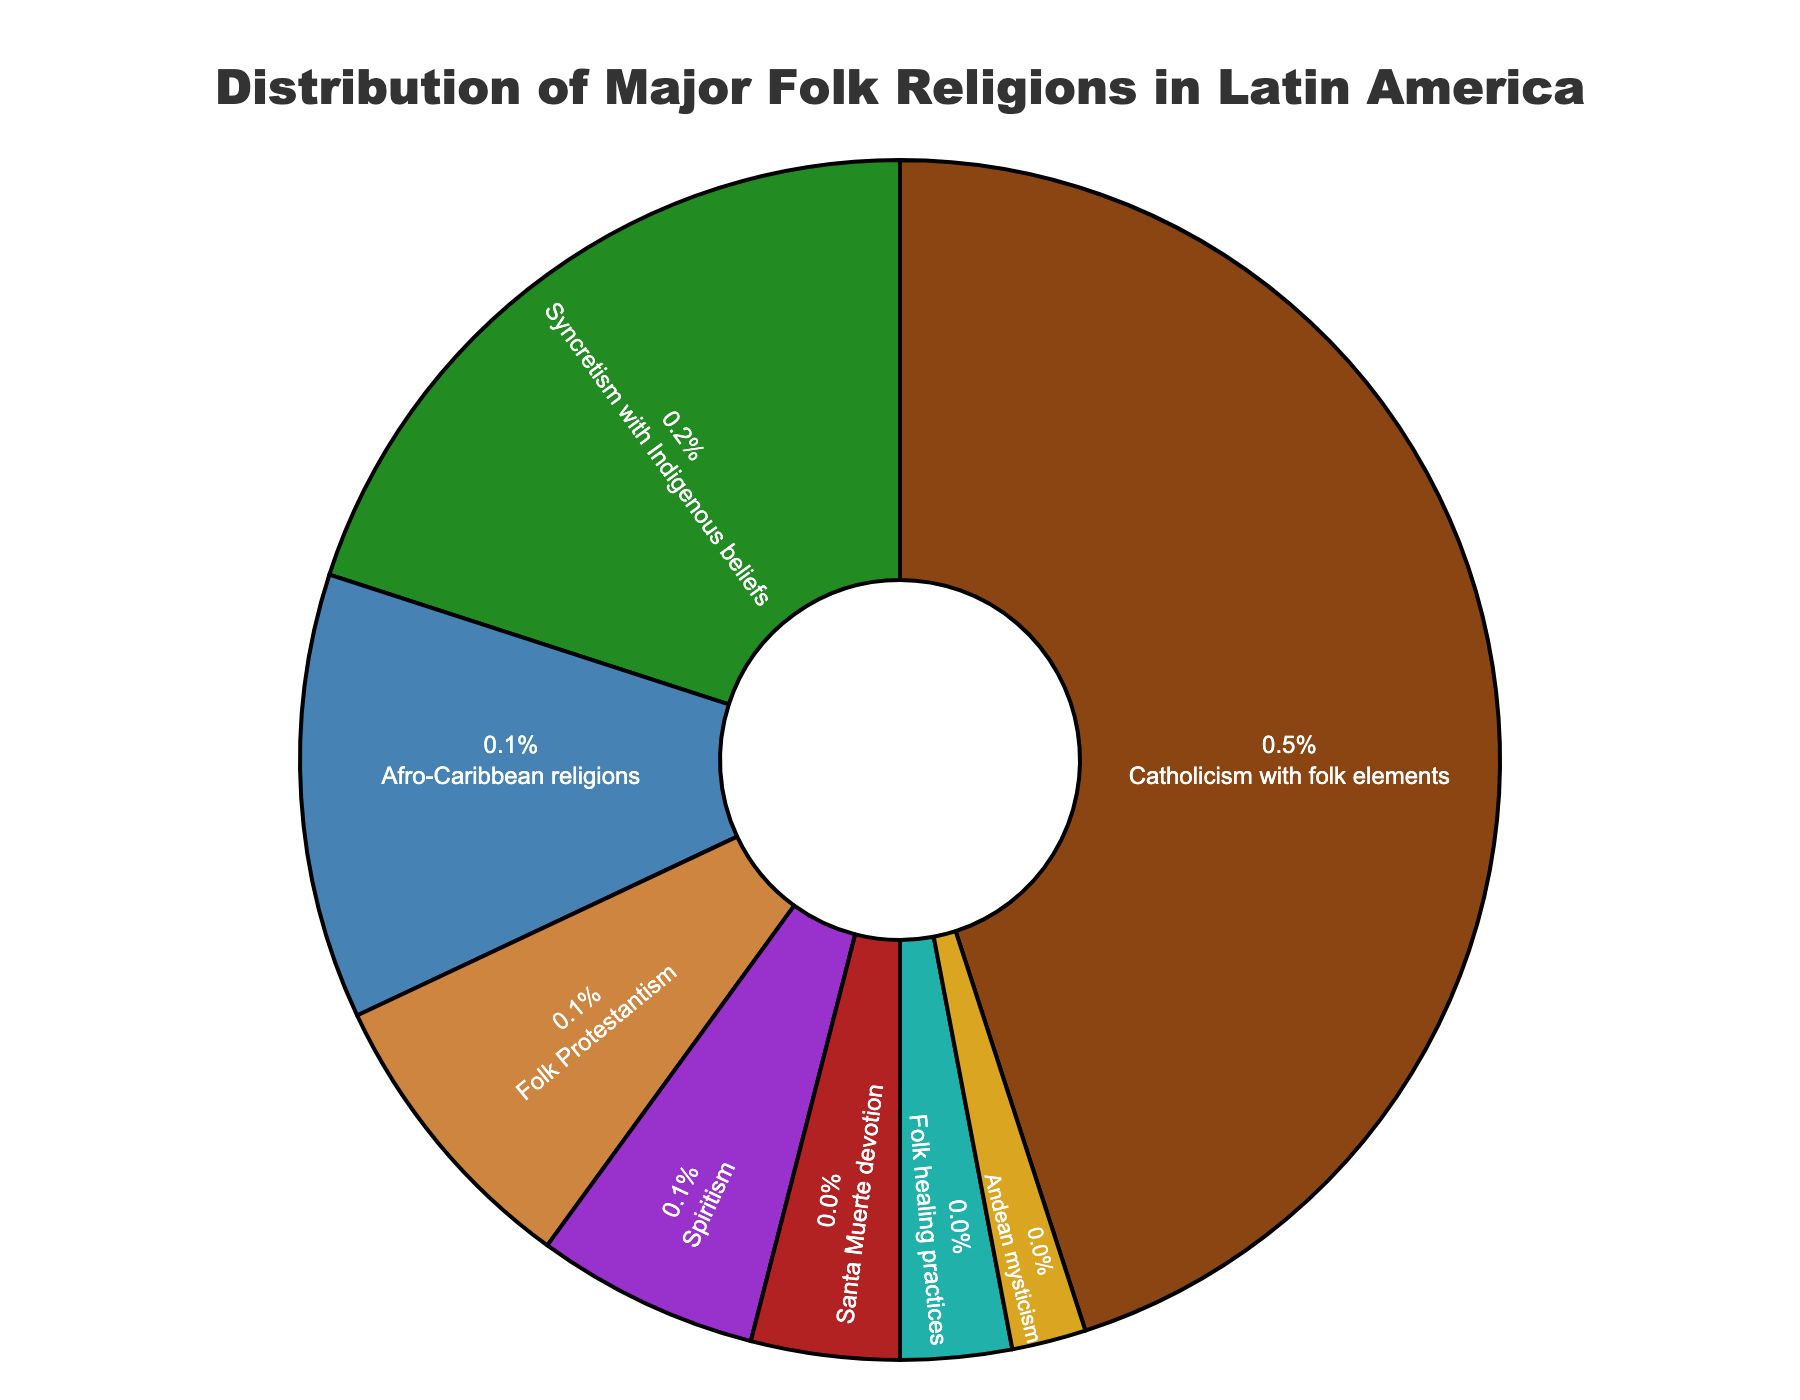Which folk religion has the highest percentage distribution in Latin America? The pie chart shows that "Catholicism with folk elements" occupies the largest section.
Answer: Catholicism with folk elements What is the percentage difference between "Syncretism with Indigenous beliefs" and "Afro-Caribbean religions"? The chart indicates "Syncretism with Indigenous beliefs" is 20% and "Afro-Caribbean religions" is 12%. Subtracting these values gives the difference. 20% - 12% = 8%.
Answer: 8% Which folk religions combined make up 50% of the distribution? Adding the percentages from the largest until the sum reaches or exceeds 50%. "Catholicism with folk elements" (45%) and "Syncretism with Indigenous beliefs" (20%) together make 45% + 20% = 65%, which exceeds 50%. Before 50% is reached, "Catholicism with folk elements" at 45% stands alone closest to this mark without exceeding it.
Answer: Catholicism with folk elements and Syncretism with Indigenous beliefs Is "Folk Protestantism" more or less prevalent than "Spiritism"? The pie chart shows that "Folk Protestantism" has a value of 8% while "Spiritism" has a value of 6%, indicating "Folk Protestantism" is more prevalent.
Answer: More prevalent Calculate the total percentage of folk religions excluding "Catholicism with folk elements". Summing the percentages of all religions except "Catholicism with folk elements": 20% (Syncretism with Indigenous beliefs) + 12% (Afro-Caribbean religions) + 8% (Folk Protestantism) + 6% (Spiritism) + 4% (Santa Muerte devotion) + 3% (Folk healing practices) + 2% (Andean mysticism) = 55%.
Answer: 55% What is the combined percentage of the two least prevalent folk religions? The least prevalent religions, as shown in the chart, are "Andean mysticism" (2%) and "Folk healing practices" (3%). Adding them gives 2% + 3% = 5%.
Answer: 5% Which religion has a similar percentage to the "Santa Muerte devotion"? The "Spiritism" section is closest with 6% compared to "Santa Muerte devotion" which stands at 4%.
Answer: Spiritism How many times more prevalent is "Catholicism with folk elements" compared to "Andean mysticism"? "Catholicism with folk elements" is 45%, and "Andean mysticism" is 2%. Dividing 45% by 2% gives us 45 / 2 = 22.5.
Answer: 22.5 times What percentage of the chart is occupied by religions with a green hue? The pie chart shows "Syncretism with Indigenous beliefs" in green at 20%.
Answer: 20% What is the average percentage of "Afro-Caribbean religions", "Folk Protestantism", and "Spiritism"? Adding their percentages: 12% + 8% + 6% = 26%. Dividing by 3 gives an average, 26% / 3 = 8.67%.
Answer: 8.67% 